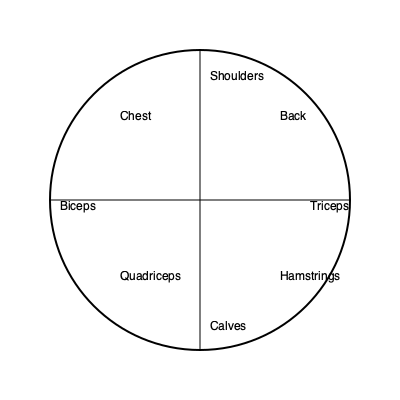Using the muscle group diagram provided, identify which two muscle groups are most heavily engaged during a swimming freestyle stroke. To answer this question, let's break down the freestyle swimming stroke and analyze which muscle groups are most heavily involved:

1. Arm movement: The freestyle stroke involves a circular arm motion that pulls the water backwards.
   - This primarily engages the shoulders for the overhead motion and rotation.
   - The back muscles are also heavily involved in pulling the arm through the water.

2. Leg movement: While legs are used in freestyle, they are not as dominant as the upper body in propelling the swimmer forward.
   - The leg kick involves some engagement of quadriceps and hamstrings, but not as intensively as the upper body muscles.

3. Core stability: The core muscles are engaged to maintain body position, but they are not one of the primary movers in this stroke.

4. Chest, biceps, and triceps: These muscle groups are involved to some extent but are not the primary drivers of the freestyle stroke.

5. Calves: While used in the kicking motion, they are not as heavily engaged as the upper body muscles.

Considering these factors, the two muscle groups most heavily engaged during a freestyle swimming stroke are the shoulders and back. These muscle groups are responsible for the powerful pulling motion that propels the swimmer through the water most effectively.
Answer: Shoulders and Back 